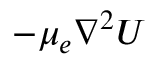<formula> <loc_0><loc_0><loc_500><loc_500>- \mu _ { e } \nabla ^ { 2 } U</formula> 